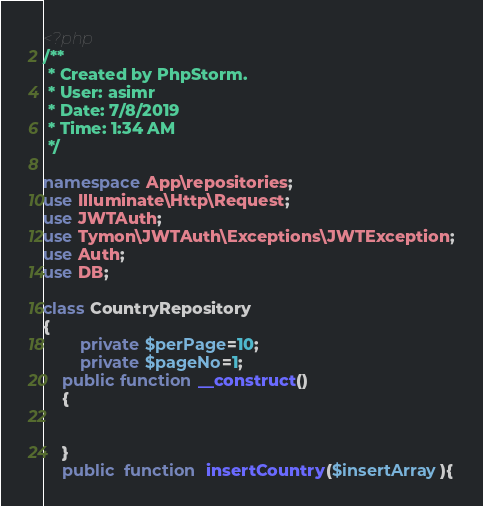Convert code to text. <code><loc_0><loc_0><loc_500><loc_500><_PHP_><?php
/**
 * Created by PhpStorm.
 * User: asimr
 * Date: 7/8/2019
 * Time: 1:34 AM
 */

namespace App\repositories;
use Illuminate\Http\Request;
use JWTAuth;
use Tymon\JWTAuth\Exceptions\JWTException;
use Auth;
use DB;

class CountryRepository
{
        private $perPage=10;
        private $pageNo=1;
    public function __construct()
    {


    }
    public  function  insertCountry($insertArray){</code> 